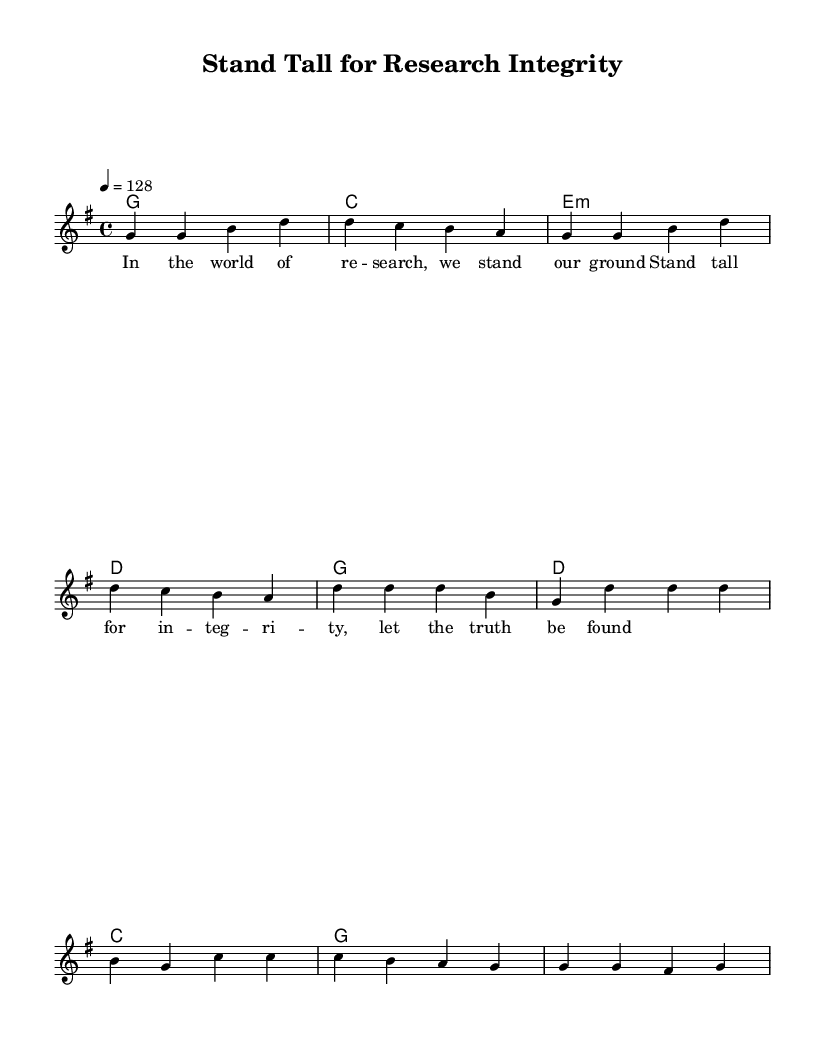What is the key signature of this music? The key signature is G major, which has one sharp (F#). This can be seen at the beginning of the sheet music, where the key signature is notated.
Answer: G major What is the time signature of the piece? The time signature is 4/4, indicated right after the key signature. It shows that there are four beats per measure and that the quarter note gets one beat.
Answer: 4/4 What is the tempo marking for this piece? The tempo marking is 128 beats per minute, indicated as "4 = 128" at the top of the sheet music. This indicates the speed at which the piece should be played.
Answer: 128 How many measures are in the verse section? The verse section consists of four measures, which can be determined by counting the separated sections of the melody.
Answer: 4 What is the primary theme of the lyrics in this anthem? The primary theme of the lyrics focuses on standing up for integrity in research. This is derived from the lyrical content presented above the melody, emphasizing values in research.
Answer: Integrity Which chord follows the first measure of the verse? The chord following the first measure of the verse is a G major chord, which is noted as "g1" in the harmonies section. This chord supports the melody occurring in that measure.
Answer: G 